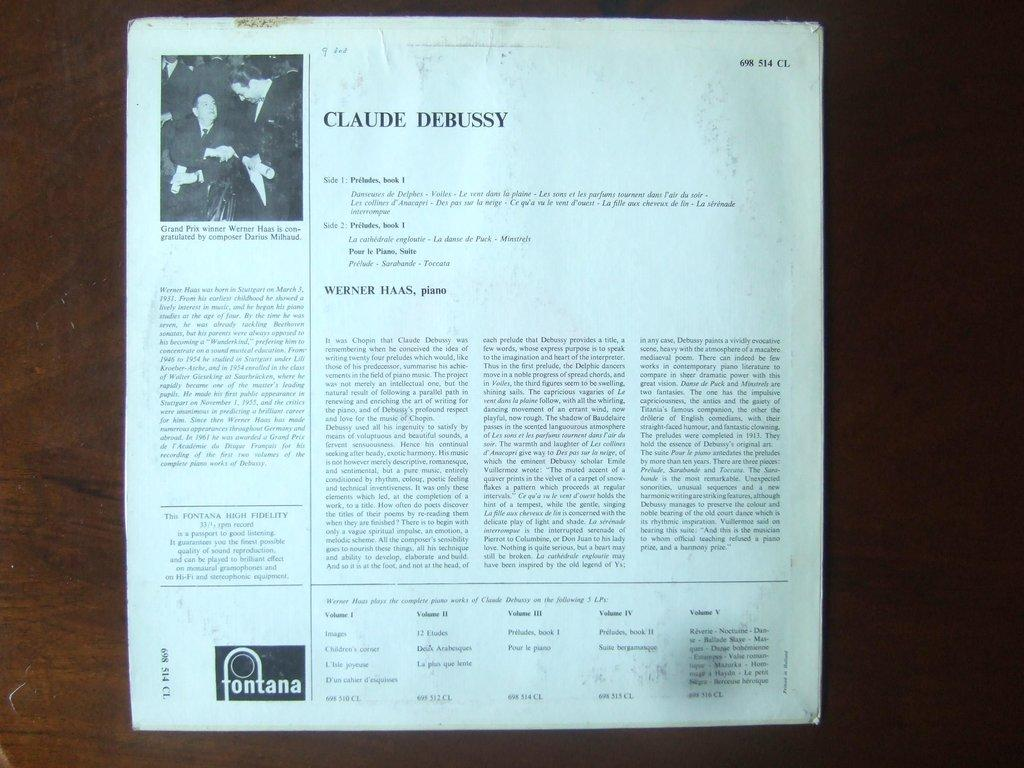<image>
Render a clear and concise summary of the photo. The back of an album cover provides details on Claude Debussy. 